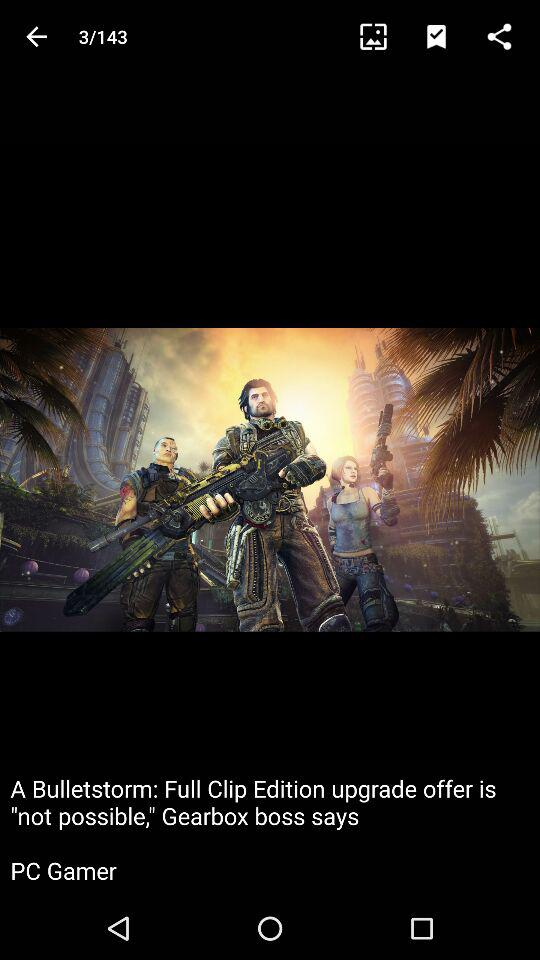How many images are there? There are 143 images. 